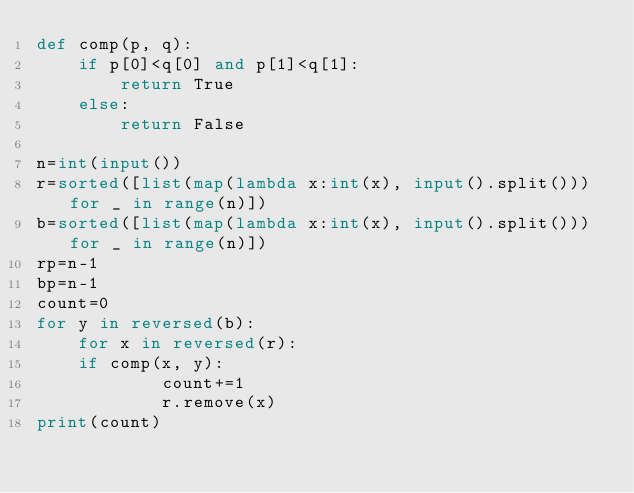<code> <loc_0><loc_0><loc_500><loc_500><_Python_>def comp(p, q):
    if p[0]<q[0] and p[1]<q[1]:
        return True
    else:
        return False
 
n=int(input())
r=sorted([list(map(lambda x:int(x), input().split())) for _ in range(n)])
b=sorted([list(map(lambda x:int(x), input().split())) for _ in range(n)])
rp=n-1
bp=n-1
count=0
for y in reversed(b):
    for x in reversed(r):
	if comp(x, y):
            count+=1
            r.remove(x)
print(count)</code> 